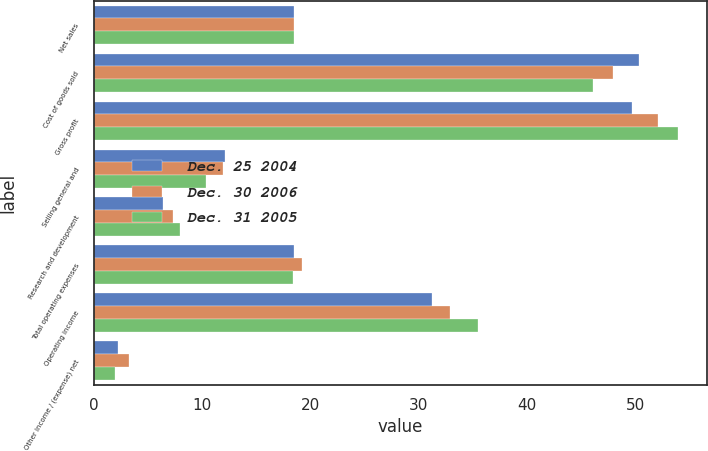Convert chart to OTSL. <chart><loc_0><loc_0><loc_500><loc_500><stacked_bar_chart><ecel><fcel>Net sales<fcel>Cost of goods sold<fcel>Gross profit<fcel>Selling general and<fcel>Research and development<fcel>Total operating expenses<fcel>Operating income<fcel>Other income / (expense) net<nl><fcel>Dec. 25 2004<fcel>18.5<fcel>50.3<fcel>49.7<fcel>12.1<fcel>6.4<fcel>18.5<fcel>31.2<fcel>2.3<nl><fcel>Dec. 30 2006<fcel>18.5<fcel>47.9<fcel>52.1<fcel>11.9<fcel>7.3<fcel>19.2<fcel>32.9<fcel>3.3<nl><fcel>Dec. 31 2005<fcel>18.5<fcel>46.1<fcel>53.9<fcel>10.4<fcel>8<fcel>18.4<fcel>35.5<fcel>2<nl></chart> 